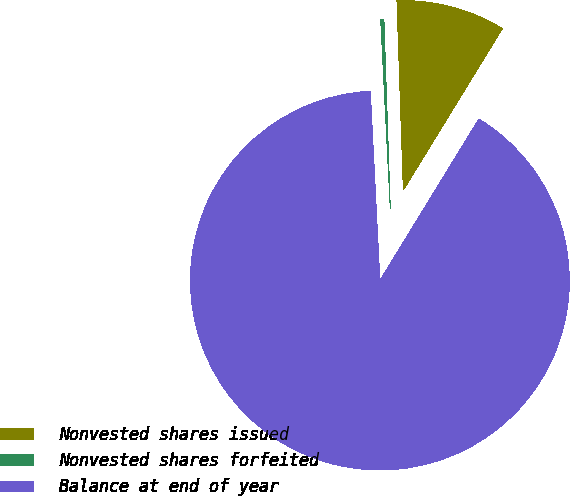<chart> <loc_0><loc_0><loc_500><loc_500><pie_chart><fcel>Nonvested shares issued<fcel>Nonvested shares forfeited<fcel>Balance at end of year<nl><fcel>9.29%<fcel>0.27%<fcel>90.45%<nl></chart> 